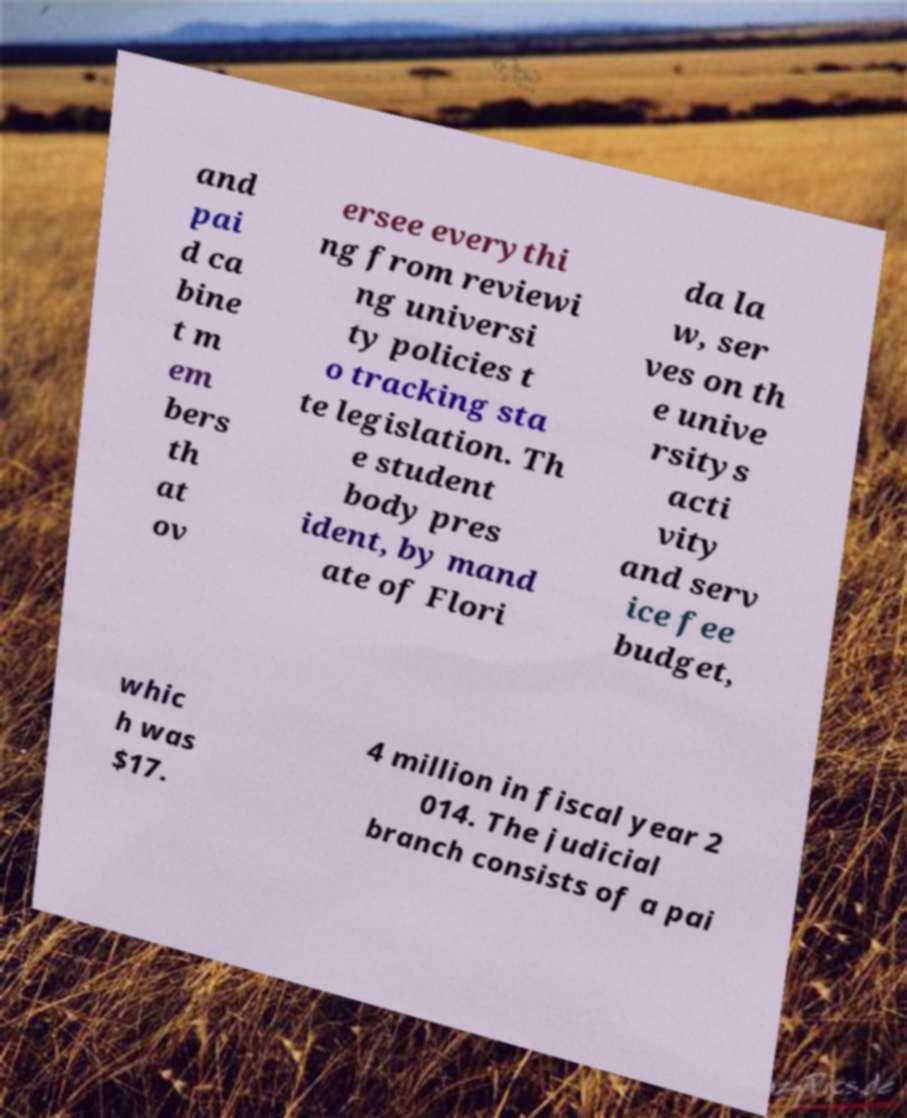Could you assist in decoding the text presented in this image and type it out clearly? and pai d ca bine t m em bers th at ov ersee everythi ng from reviewi ng universi ty policies t o tracking sta te legislation. Th e student body pres ident, by mand ate of Flori da la w, ser ves on th e unive rsitys acti vity and serv ice fee budget, whic h was $17. 4 million in fiscal year 2 014. The judicial branch consists of a pai 